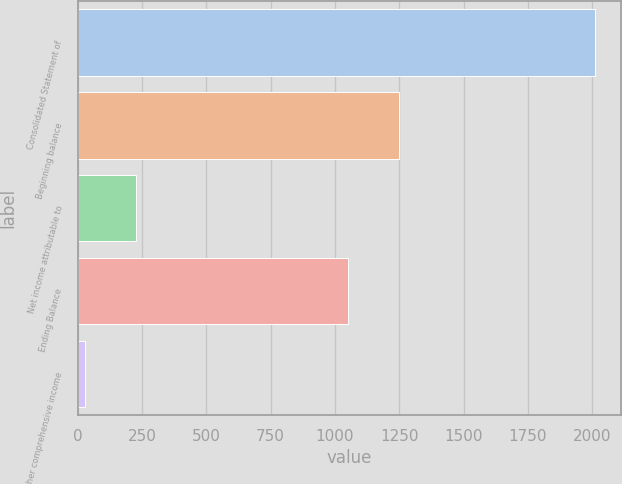Convert chart to OTSL. <chart><loc_0><loc_0><loc_500><loc_500><bar_chart><fcel>Consolidated Statement of<fcel>Beginning balance<fcel>Net income attributable to<fcel>Ending Balance<fcel>Other comprehensive income<nl><fcel>2010<fcel>1249<fcel>228<fcel>1051<fcel>30<nl></chart> 